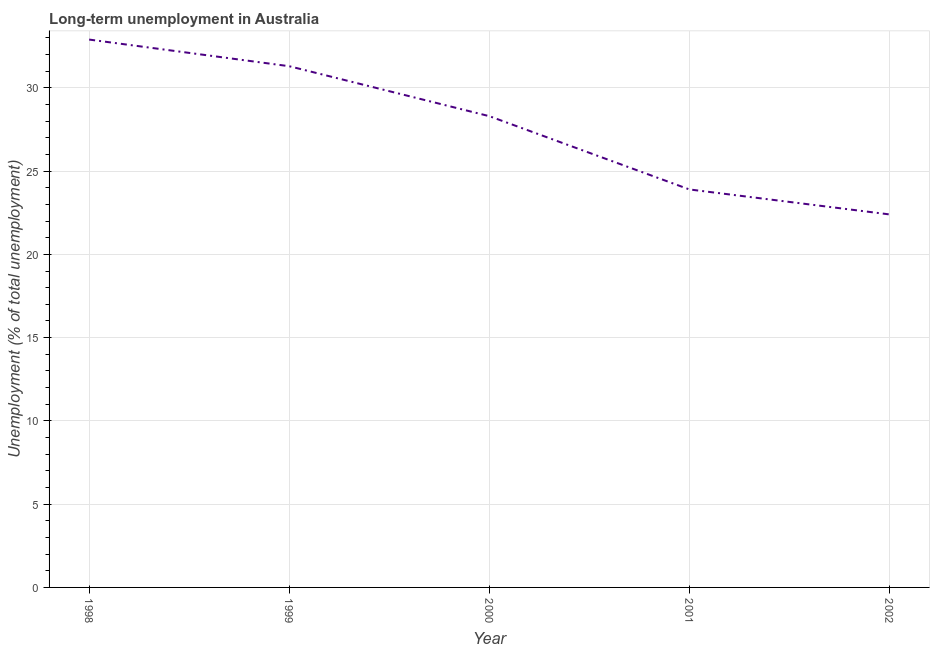What is the long-term unemployment in 1998?
Offer a terse response. 32.9. Across all years, what is the maximum long-term unemployment?
Your answer should be compact. 32.9. Across all years, what is the minimum long-term unemployment?
Your answer should be compact. 22.4. In which year was the long-term unemployment maximum?
Offer a terse response. 1998. What is the sum of the long-term unemployment?
Give a very brief answer. 138.8. What is the difference between the long-term unemployment in 1999 and 2001?
Provide a short and direct response. 7.4. What is the average long-term unemployment per year?
Ensure brevity in your answer.  27.76. What is the median long-term unemployment?
Give a very brief answer. 28.3. Do a majority of the years between 1999 and 2000 (inclusive) have long-term unemployment greater than 23 %?
Keep it short and to the point. Yes. What is the ratio of the long-term unemployment in 2001 to that in 2002?
Offer a terse response. 1.07. What is the difference between the highest and the second highest long-term unemployment?
Offer a very short reply. 1.6. What is the difference between the highest and the lowest long-term unemployment?
Your answer should be compact. 10.5. In how many years, is the long-term unemployment greater than the average long-term unemployment taken over all years?
Your answer should be very brief. 3. Does the long-term unemployment monotonically increase over the years?
Provide a succinct answer. No. How many years are there in the graph?
Offer a very short reply. 5. Are the values on the major ticks of Y-axis written in scientific E-notation?
Your answer should be very brief. No. Does the graph contain any zero values?
Ensure brevity in your answer.  No. What is the title of the graph?
Make the answer very short. Long-term unemployment in Australia. What is the label or title of the X-axis?
Your answer should be compact. Year. What is the label or title of the Y-axis?
Your answer should be compact. Unemployment (% of total unemployment). What is the Unemployment (% of total unemployment) in 1998?
Give a very brief answer. 32.9. What is the Unemployment (% of total unemployment) of 1999?
Offer a terse response. 31.3. What is the Unemployment (% of total unemployment) of 2000?
Your answer should be compact. 28.3. What is the Unemployment (% of total unemployment) in 2001?
Provide a succinct answer. 23.9. What is the Unemployment (% of total unemployment) of 2002?
Ensure brevity in your answer.  22.4. What is the difference between the Unemployment (% of total unemployment) in 1998 and 2001?
Give a very brief answer. 9. What is the difference between the Unemployment (% of total unemployment) in 1998 and 2002?
Offer a terse response. 10.5. What is the difference between the Unemployment (% of total unemployment) in 2000 and 2002?
Your answer should be very brief. 5.9. What is the ratio of the Unemployment (% of total unemployment) in 1998 to that in 1999?
Provide a succinct answer. 1.05. What is the ratio of the Unemployment (% of total unemployment) in 1998 to that in 2000?
Your answer should be very brief. 1.16. What is the ratio of the Unemployment (% of total unemployment) in 1998 to that in 2001?
Keep it short and to the point. 1.38. What is the ratio of the Unemployment (% of total unemployment) in 1998 to that in 2002?
Keep it short and to the point. 1.47. What is the ratio of the Unemployment (% of total unemployment) in 1999 to that in 2000?
Your answer should be compact. 1.11. What is the ratio of the Unemployment (% of total unemployment) in 1999 to that in 2001?
Provide a short and direct response. 1.31. What is the ratio of the Unemployment (% of total unemployment) in 1999 to that in 2002?
Make the answer very short. 1.4. What is the ratio of the Unemployment (% of total unemployment) in 2000 to that in 2001?
Your answer should be very brief. 1.18. What is the ratio of the Unemployment (% of total unemployment) in 2000 to that in 2002?
Offer a very short reply. 1.26. What is the ratio of the Unemployment (% of total unemployment) in 2001 to that in 2002?
Provide a short and direct response. 1.07. 